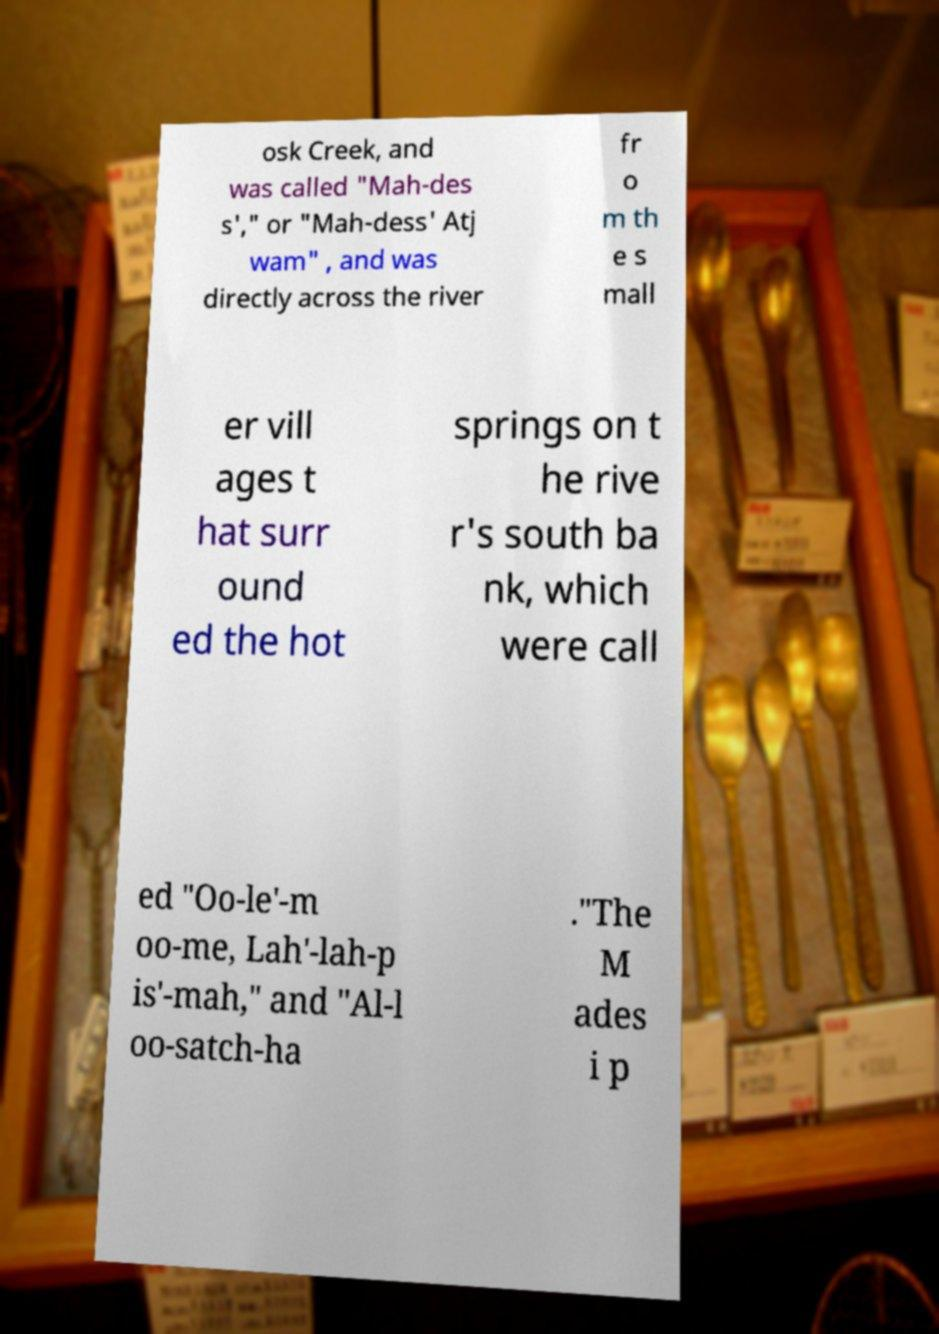Please identify and transcribe the text found in this image. osk Creek, and was called "Mah-des s'," or "Mah-dess' Atj wam" , and was directly across the river fr o m th e s mall er vill ages t hat surr ound ed the hot springs on t he rive r's south ba nk, which were call ed "Oo-le'-m oo-me, Lah'-lah-p is'-mah," and "Al-l oo-satch-ha ."The M ades i p 